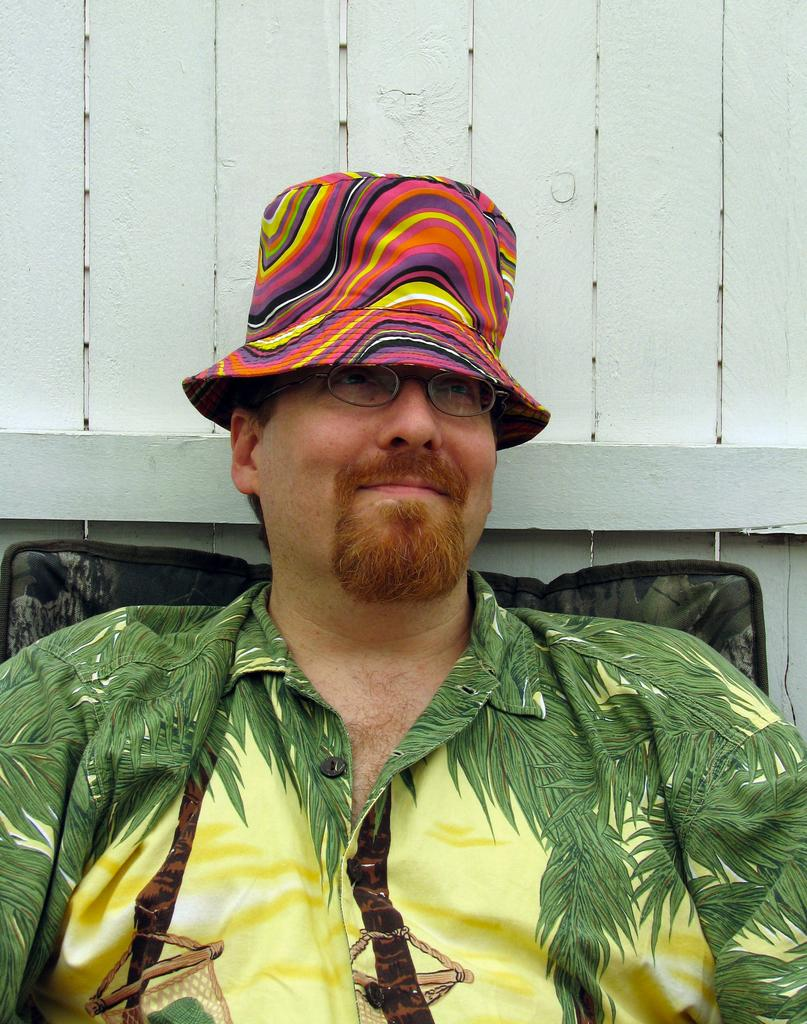Who is the main subject in the image? There is a man in the image. Where is the man located in the image? The man is sitting in the center of the image. What is the man wearing on his head? The man is wearing a hat. What type of expansion is the man experiencing in the image? There is no indication of any expansion in the image; the man is simply sitting and wearing a hat. 